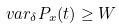<formula> <loc_0><loc_0><loc_500><loc_500>\ v a r _ { \delta } P _ { x } ( t ) \geq W</formula> 